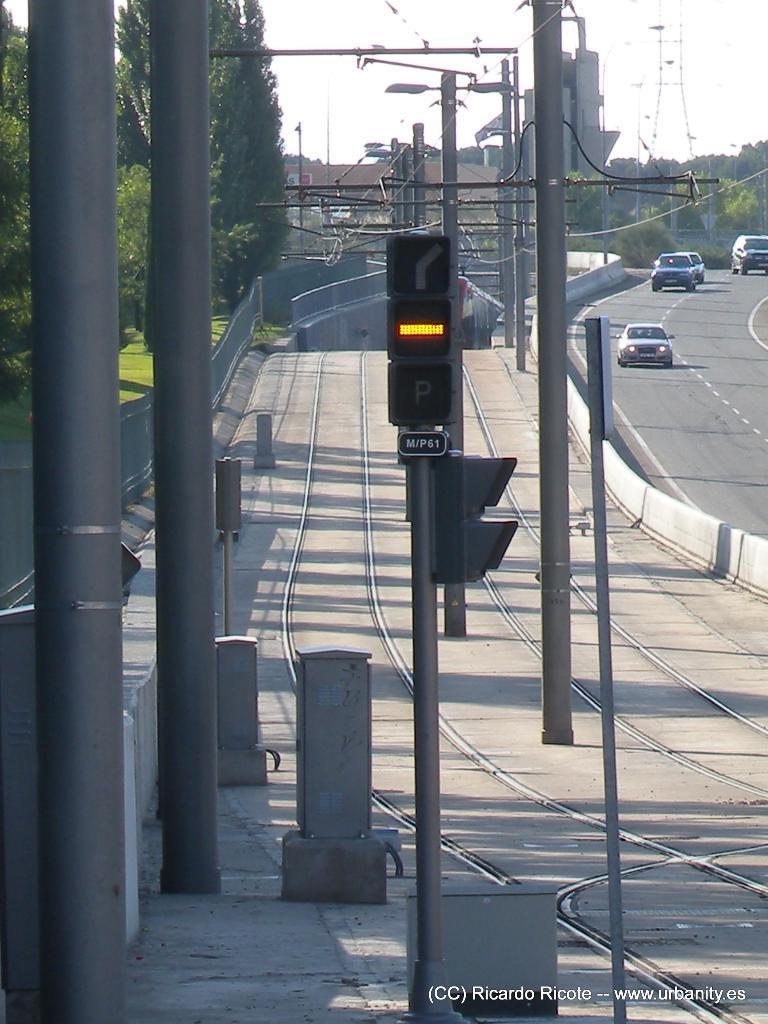Can you describe this image briefly? In this image we can see some poles, electric wires, railway tracks and on right side of the image there is road on which there are some vehicles moving and in the background of the image there are some houses, trees and clear sky. 